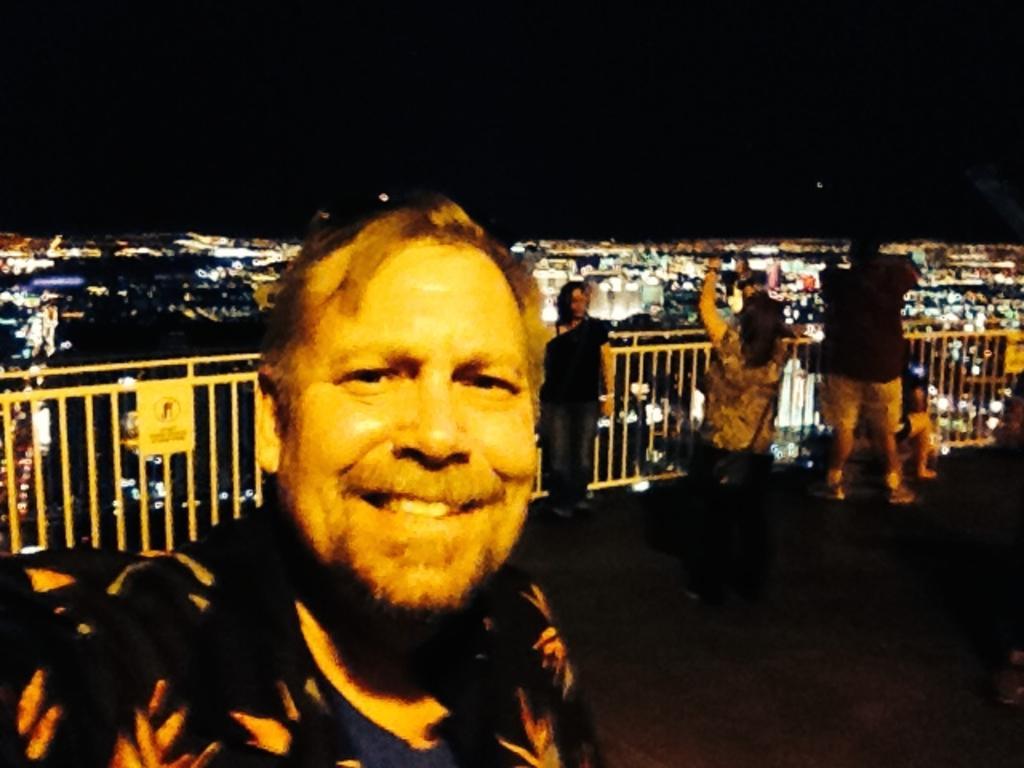Can you describe this image briefly? In the foreground of the picture we can see people and railing. In the middle it is an aerial view of a city, we can see buildings and light. At the top there is sky. 